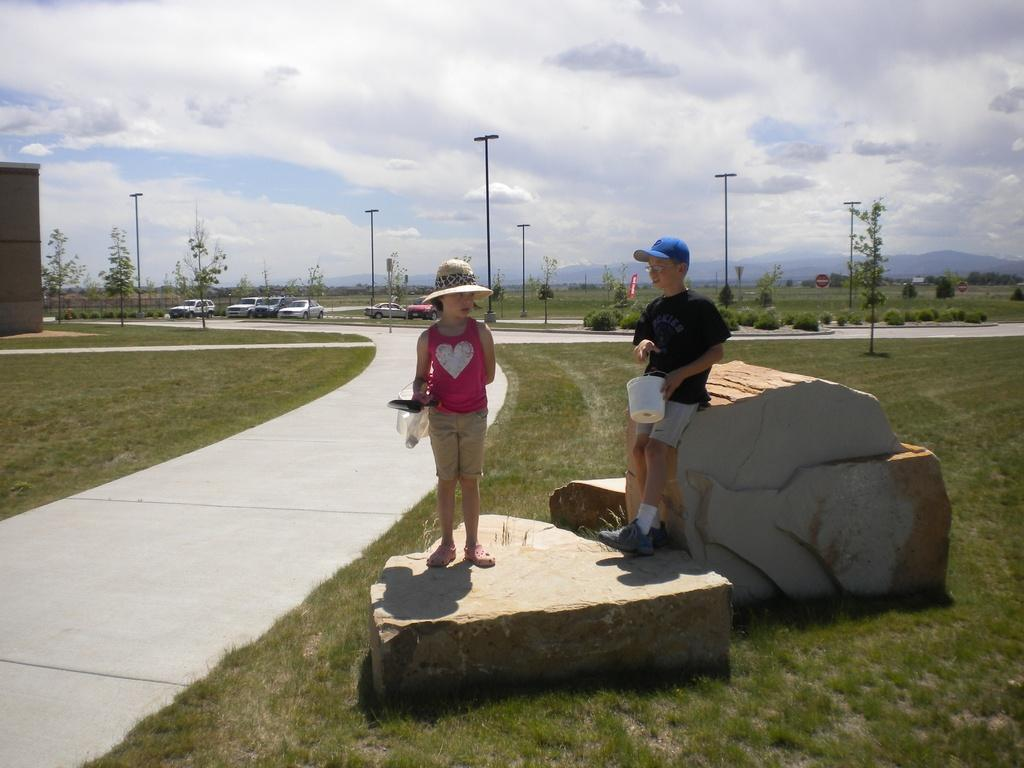How many children are in the image? There are two children in the image. Where are the children standing? The children are standing on a rock. What type of vegetation is present in the image? Grass, plants, and trees are visible in the image. What kind of path can be seen in the image? There is a path in the image. What are the poles used for in the image? The purpose of the poles is not specified in the image. What types of vehicles are visible in the image? Vehicles are visible in the image, but their specific types are not mentioned. What is visible in the background of the image? The sky is visible in the background of the image, with clouds present. What type of machine is being used to cook the beef in the image? There is no machine, beef, or cooking activity present in the image. 